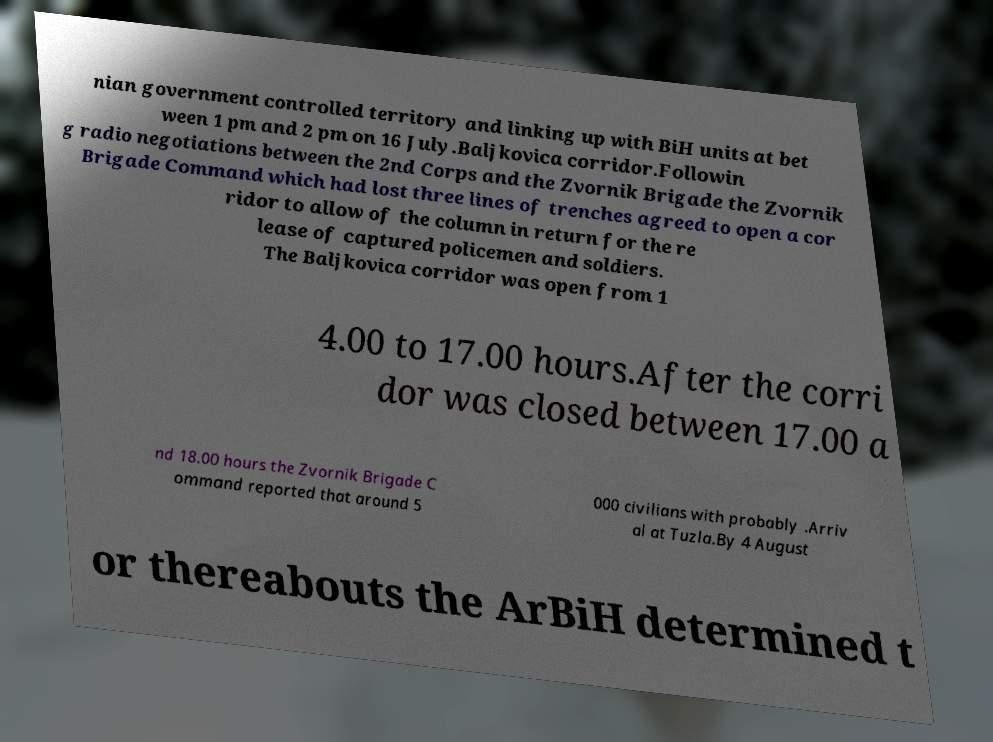What messages or text are displayed in this image? I need them in a readable, typed format. nian government controlled territory and linking up with BiH units at bet ween 1 pm and 2 pm on 16 July.Baljkovica corridor.Followin g radio negotiations between the 2nd Corps and the Zvornik Brigade the Zvornik Brigade Command which had lost three lines of trenches agreed to open a cor ridor to allow of the column in return for the re lease of captured policemen and soldiers. The Baljkovica corridor was open from 1 4.00 to 17.00 hours.After the corri dor was closed between 17.00 a nd 18.00 hours the Zvornik Brigade C ommand reported that around 5 000 civilians with probably .Arriv al at Tuzla.By 4 August or thereabouts the ArBiH determined t 